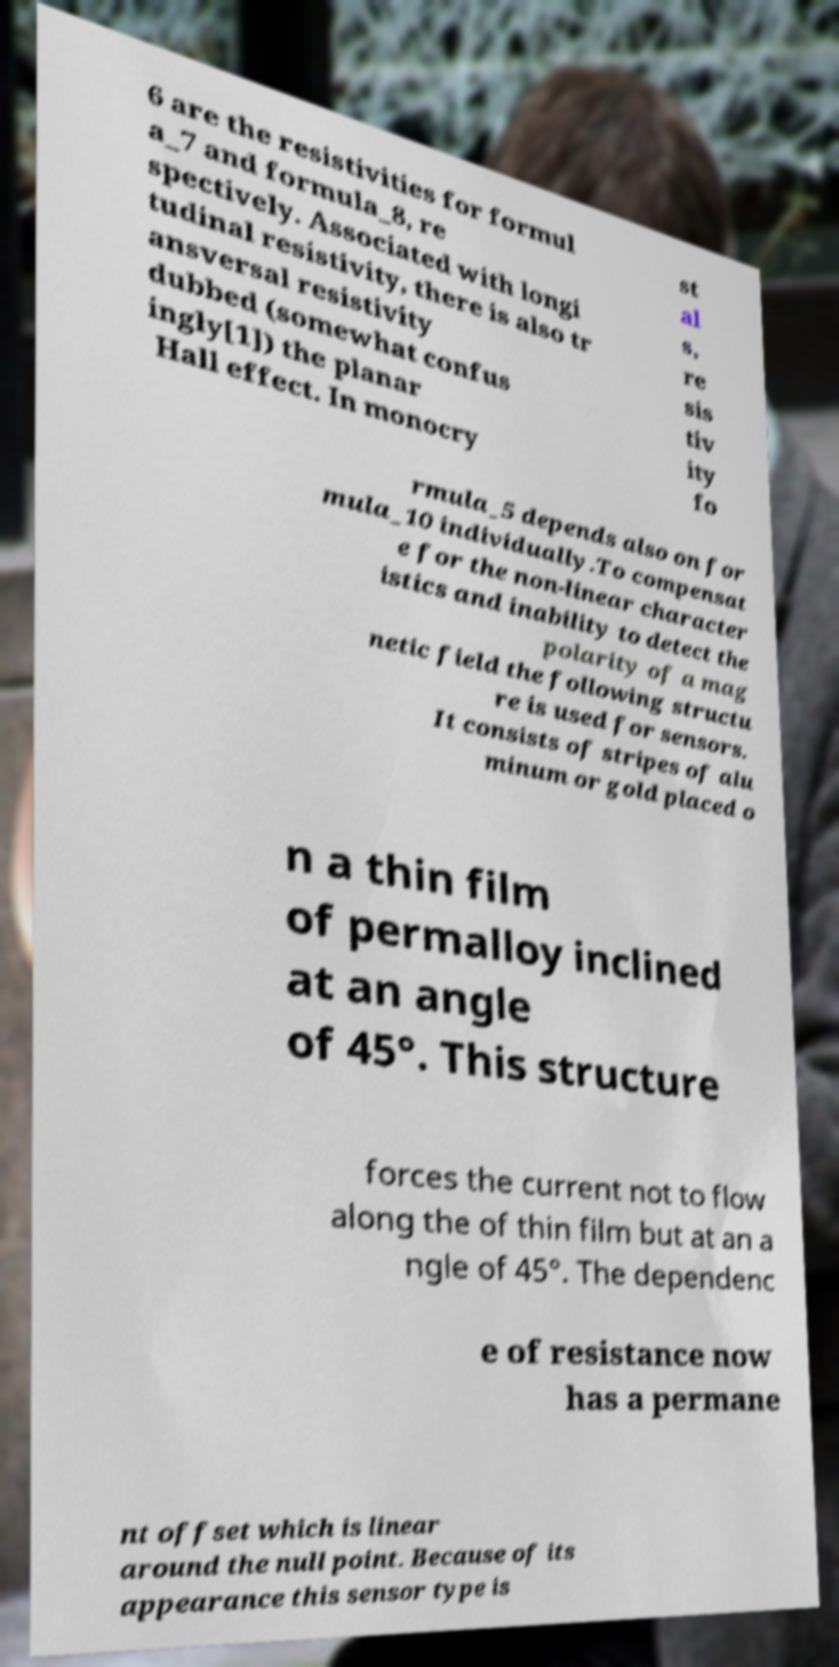There's text embedded in this image that I need extracted. Can you transcribe it verbatim? 6 are the resistivities for formul a_7 and formula_8, re spectively. Associated with longi tudinal resistivity, there is also tr ansversal resistivity dubbed (somewhat confus ingly[1]) the planar Hall effect. In monocry st al s, re sis tiv ity fo rmula_5 depends also on for mula_10 individually.To compensat e for the non-linear character istics and inability to detect the polarity of a mag netic field the following structu re is used for sensors. It consists of stripes of alu minum or gold placed o n a thin film of permalloy inclined at an angle of 45°. This structure forces the current not to flow along the of thin film but at an a ngle of 45°. The dependenc e of resistance now has a permane nt offset which is linear around the null point. Because of its appearance this sensor type is 